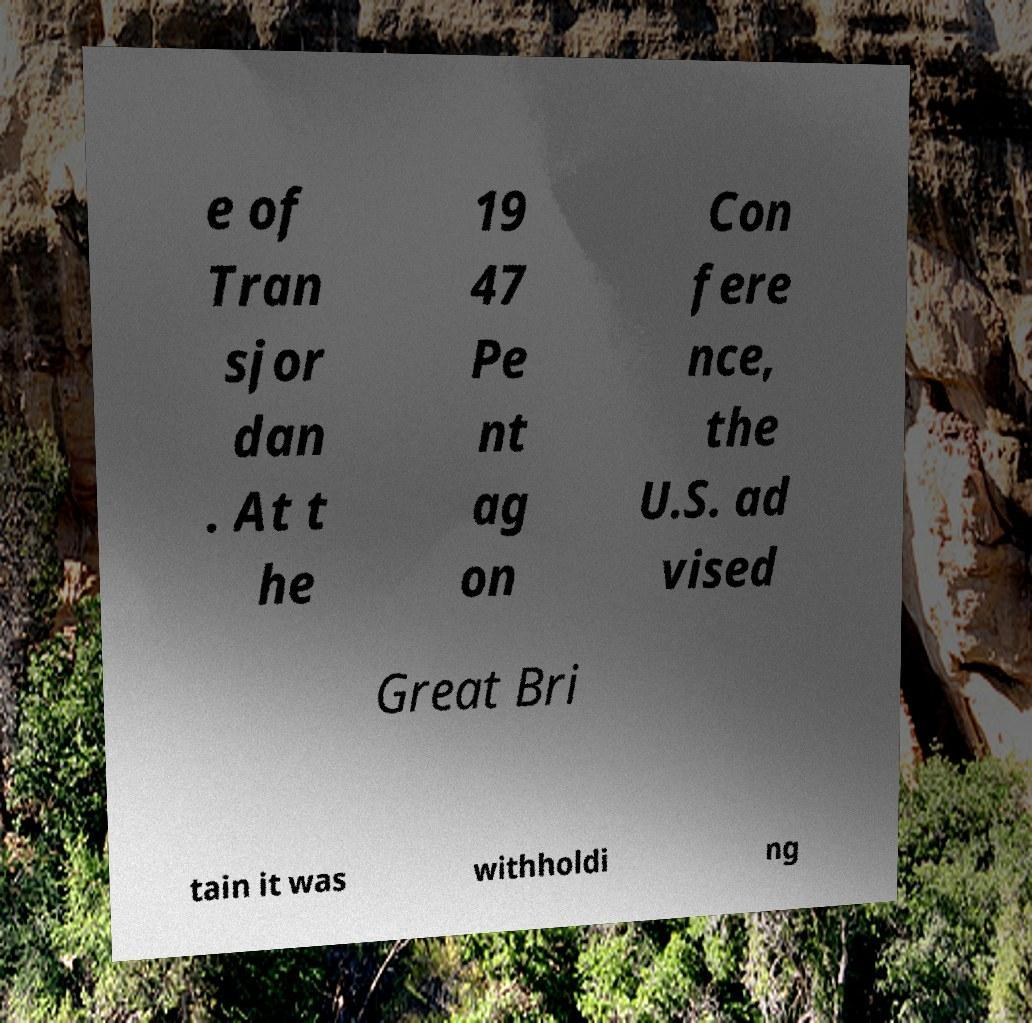Can you accurately transcribe the text from the provided image for me? e of Tran sjor dan . At t he 19 47 Pe nt ag on Con fere nce, the U.S. ad vised Great Bri tain it was withholdi ng 